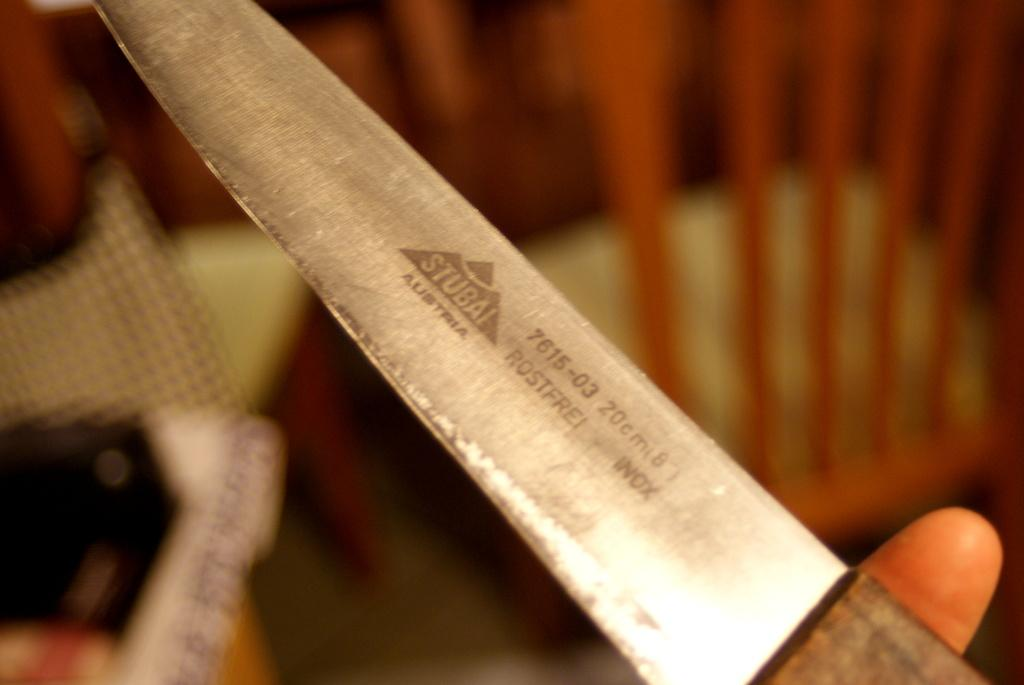What object can be seen in the image? There is a knife in the image. Can you describe the background of the image? The background of the image is blurred. How many apples are on the table next to the knife in the image? There is no table or apples present in the image; only the knife and a blurred background are visible. 